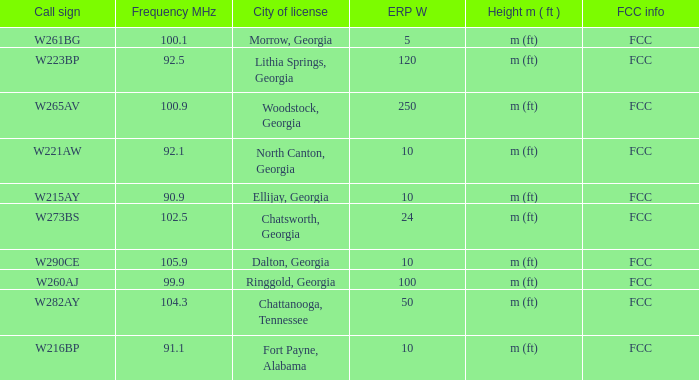What city of license has a frequency mhz below 10 Lithia Springs, Georgia. Parse the full table. {'header': ['Call sign', 'Frequency MHz', 'City of license', 'ERP W', 'Height m ( ft )', 'FCC info'], 'rows': [['W261BG', '100.1', 'Morrow, Georgia', '5', 'm (ft)', 'FCC'], ['W223BP', '92.5', 'Lithia Springs, Georgia', '120', 'm (ft)', 'FCC'], ['W265AV', '100.9', 'Woodstock, Georgia', '250', 'm (ft)', 'FCC'], ['W221AW', '92.1', 'North Canton, Georgia', '10', 'm (ft)', 'FCC'], ['W215AY', '90.9', 'Ellijay, Georgia', '10', 'm (ft)', 'FCC'], ['W273BS', '102.5', 'Chatsworth, Georgia', '24', 'm (ft)', 'FCC'], ['W290CE', '105.9', 'Dalton, Georgia', '10', 'm (ft)', 'FCC'], ['W260AJ', '99.9', 'Ringgold, Georgia', '100', 'm (ft)', 'FCC'], ['W282AY', '104.3', 'Chattanooga, Tennessee', '50', 'm (ft)', 'FCC'], ['W216BP', '91.1', 'Fort Payne, Alabama', '10', 'm (ft)', 'FCC']]} 